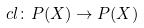Convert formula to latex. <formula><loc_0><loc_0><loc_500><loc_500>c l \colon P ( X ) \rightarrow P ( X )</formula> 